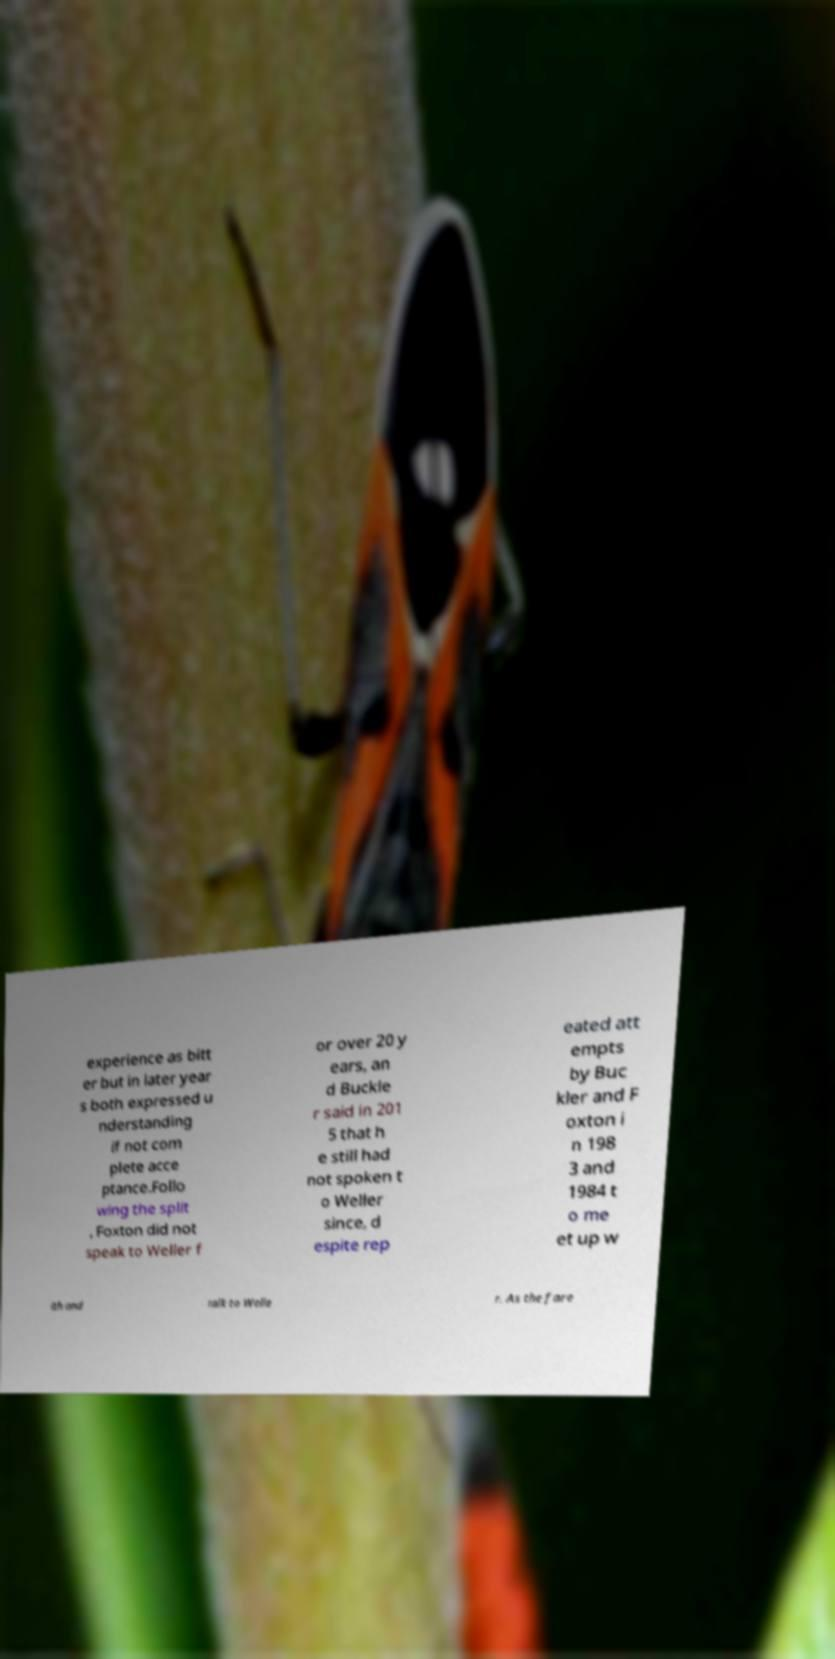Can you accurately transcribe the text from the provided image for me? experience as bitt er but in later year s both expressed u nderstanding if not com plete acce ptance.Follo wing the split , Foxton did not speak to Weller f or over 20 y ears, an d Buckle r said in 201 5 that h e still had not spoken t o Weller since, d espite rep eated att empts by Buc kler and F oxton i n 198 3 and 1984 t o me et up w ith and talk to Welle r. As the fare 